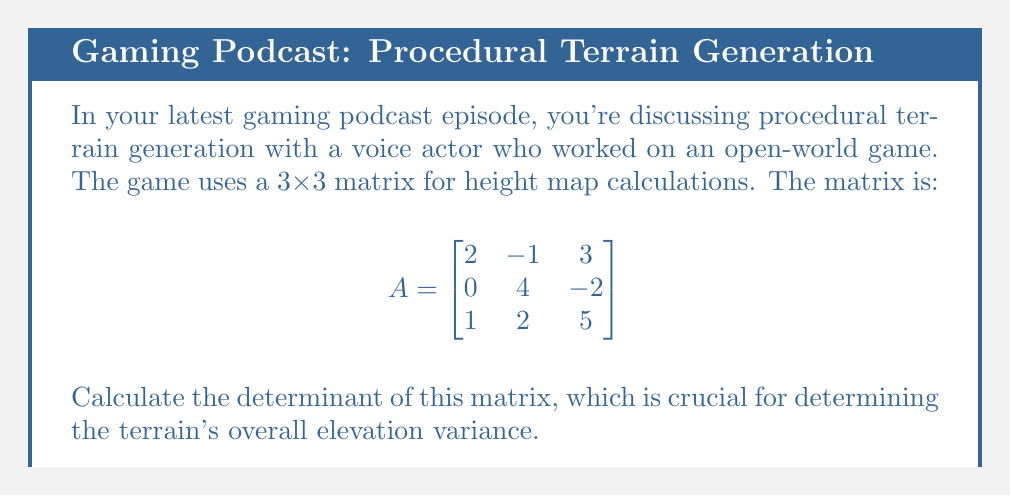Give your solution to this math problem. Let's calculate the determinant using the Laplace expansion along the first row:

1) The determinant of a 3x3 matrix $A = [a_{ij}]$ is given by:

   $\det(A) = a_{11}M_{11} - a_{12}M_{12} + a_{13}M_{13}$

   where $M_{ij}$ is the minor of $a_{ij}$ (determinant of the 2x2 matrix formed by removing row i and column j).

2) For our matrix:
   
   $\det(A) = 2M_{11} - (-1)M_{12} + 3M_{13}$

3) Calculate the minors:

   $M_{11} = \det\begin{bmatrix}4 & -2 \\ 2 & 5\end{bmatrix} = 4(5) - (-2)(2) = 20 + 4 = 24$
   
   $M_{12} = \det\begin{bmatrix}0 & -2 \\ 1 & 5\end{bmatrix} = 0(5) - (-2)(1) = 0 + 2 = 2$
   
   $M_{13} = \det\begin{bmatrix}0 & 4 \\ 1 & 2\end{bmatrix} = 0(2) - 4(1) = 0 - 4 = -4$

4) Substitute these values into the determinant formula:

   $\det(A) = 2(24) - (-1)(2) + 3(-4)$

5) Simplify:

   $\det(A) = 48 + 2 - 12 = 38$

Therefore, the determinant of the matrix is 38.
Answer: $38$ 